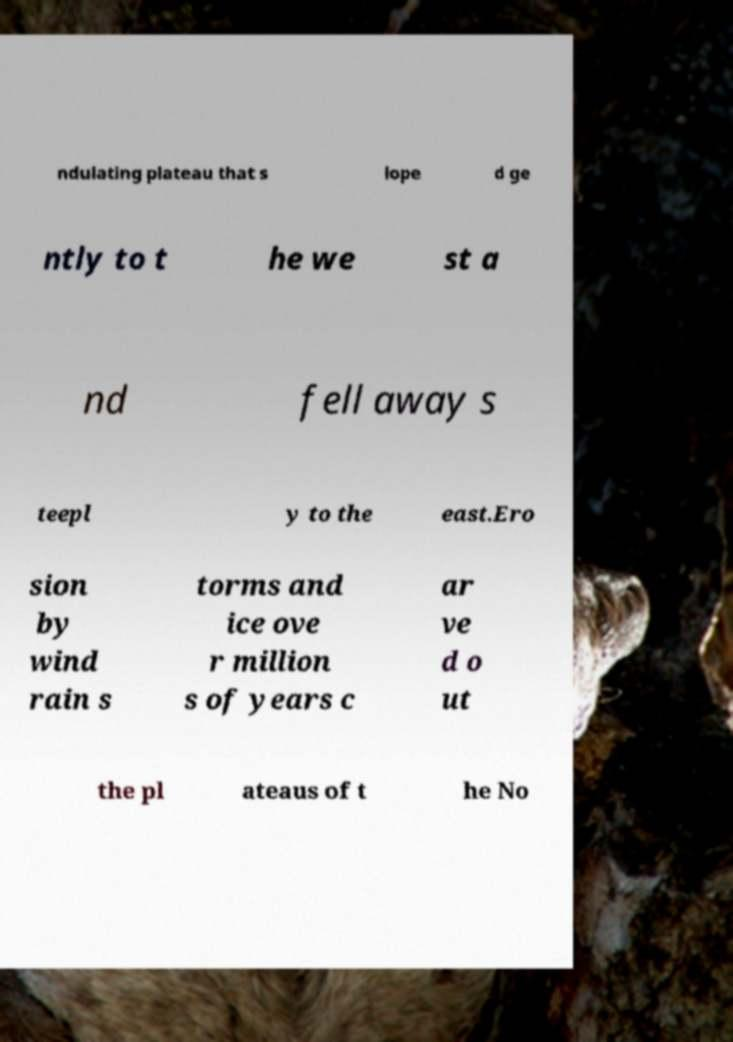Can you accurately transcribe the text from the provided image for me? ndulating plateau that s lope d ge ntly to t he we st a nd fell away s teepl y to the east.Ero sion by wind rain s torms and ice ove r million s of years c ar ve d o ut the pl ateaus of t he No 